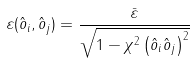<formula> <loc_0><loc_0><loc_500><loc_500>\varepsilon ( \hat { o } _ { i } , \hat { o } _ { j } ) = \frac { \bar { \varepsilon } } { \sqrt { 1 - \chi ^ { 2 } \left ( \hat { o } _ { i } \hat { o } _ { j } \right ) ^ { 2 } } }</formula> 